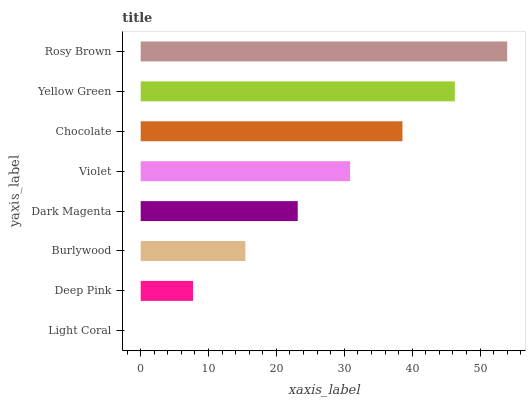Is Light Coral the minimum?
Answer yes or no. Yes. Is Rosy Brown the maximum?
Answer yes or no. Yes. Is Deep Pink the minimum?
Answer yes or no. No. Is Deep Pink the maximum?
Answer yes or no. No. Is Deep Pink greater than Light Coral?
Answer yes or no. Yes. Is Light Coral less than Deep Pink?
Answer yes or no. Yes. Is Light Coral greater than Deep Pink?
Answer yes or no. No. Is Deep Pink less than Light Coral?
Answer yes or no. No. Is Violet the high median?
Answer yes or no. Yes. Is Dark Magenta the low median?
Answer yes or no. Yes. Is Dark Magenta the high median?
Answer yes or no. No. Is Light Coral the low median?
Answer yes or no. No. 